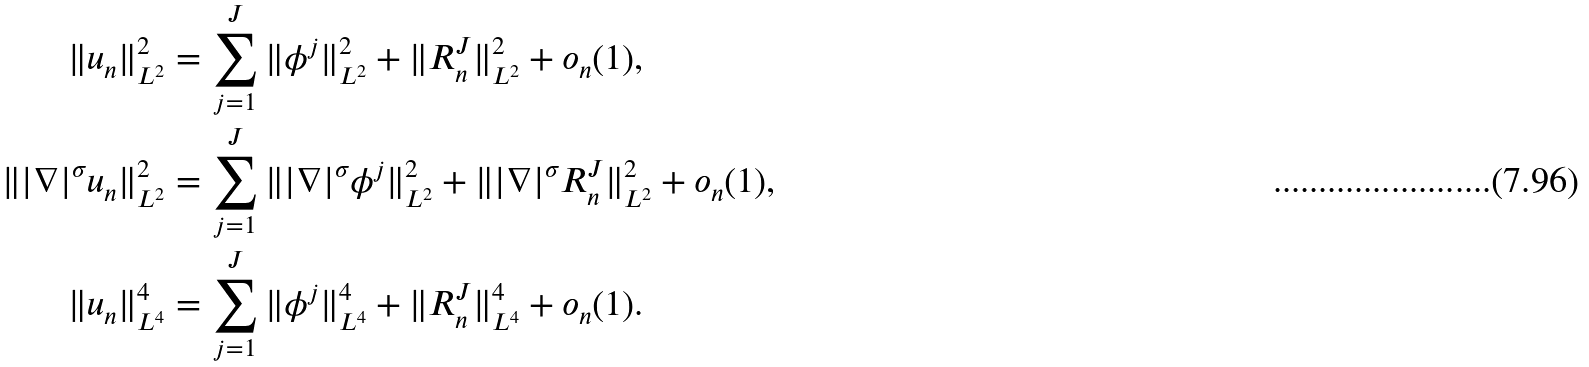<formula> <loc_0><loc_0><loc_500><loc_500>\| u _ { n } \| _ { L ^ { 2 } } ^ { 2 } & = \sum _ { j = 1 } ^ { J } \| \phi ^ { j } \| _ { L ^ { 2 } } ^ { 2 } + \| R _ { n } ^ { J } \| _ { L ^ { 2 } } ^ { 2 } + o _ { n } ( 1 ) , \\ \| | \nabla | ^ { \sigma } u _ { n } \| _ { L ^ { 2 } } ^ { 2 } & = \sum _ { j = 1 } ^ { J } \| | \nabla | ^ { \sigma } \phi ^ { j } \| _ { L ^ { 2 } } ^ { 2 } + \| | \nabla | ^ { \sigma } R _ { n } ^ { J } \| _ { L ^ { 2 } } ^ { 2 } + o _ { n } ( 1 ) , \\ \| u _ { n } \| _ { L ^ { 4 } } ^ { 4 } & = \sum _ { j = 1 } ^ { J } \| \phi ^ { j } \| _ { L ^ { 4 } } ^ { 4 } + \| R _ { n } ^ { J } \| _ { L ^ { 4 } } ^ { 4 } + o _ { n } ( 1 ) .</formula> 